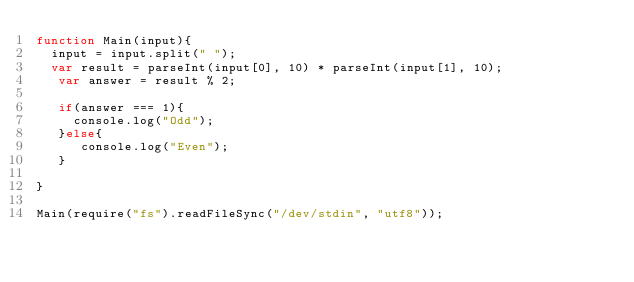Convert code to text. <code><loc_0><loc_0><loc_500><loc_500><_JavaScript_>function Main(input){
  input = input.split(" ");
  var result = parseInt(input[0], 10) * parseInt(input[1], 10);
   var answer = result % 2;
   
   if(answer === 1){
     console.log("Odd");
   }else{
      console.log("Even");
   }
   
}

Main(require("fs").readFileSync("/dev/stdin", "utf8"));</code> 